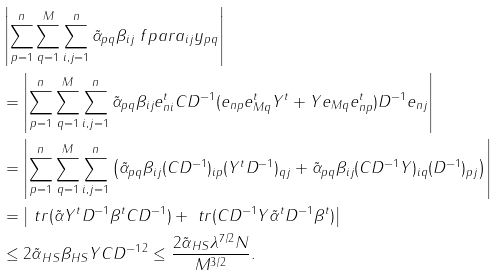Convert formula to latex. <formula><loc_0><loc_0><loc_500><loc_500>& \left | \sum _ { p = 1 } ^ { n } \sum _ { q = 1 } ^ { M } \sum _ { i , j = 1 } ^ { n } \tilde { \alpha } _ { p q } \beta _ { i j } \ f p a r { a _ { i j } } { y _ { p q } } \right | \\ & = \left | \sum _ { p = 1 } ^ { n } \sum _ { q = 1 } ^ { M } \sum _ { i , j = 1 } ^ { n } \tilde { \alpha } _ { p q } \beta _ { i j } e _ { n i } ^ { t } C D ^ { - 1 } ( e _ { n p } e _ { M q } ^ { t } Y ^ { t } + Y e _ { M q } e _ { n p } ^ { t } ) D ^ { - 1 } e _ { n j } \right | \\ & = \left | \sum _ { p = 1 } ^ { n } \sum _ { q = 1 } ^ { M } \sum _ { i , j = 1 } ^ { n } \left ( \tilde { \alpha } _ { p q } \beta _ { i j } ( C D ^ { - 1 } ) _ { i p } ( Y ^ { t } D ^ { - 1 } ) _ { q j } + \tilde { \alpha } _ { p q } \beta _ { i j } ( C D ^ { - 1 } Y ) _ { i q } ( D ^ { - 1 } ) _ { p j } \right ) \right | \\ & = \left | \ t r ( \tilde { \alpha } Y ^ { t } D ^ { - 1 } \beta ^ { t } C D ^ { - 1 } ) + \ t r ( C D ^ { - 1 } Y \tilde { \alpha } ^ { t } D ^ { - 1 } \beta ^ { t } ) \right | \\ & \leq 2 \| \tilde { \alpha } \| _ { H S } \| \beta \| _ { H S } \| Y \| C \| D ^ { - 1 } \| ^ { 2 } \leq \frac { 2 \| \tilde { \alpha } \| _ { H S } \lambda ^ { 7 / 2 } N } { M ^ { 3 / 2 } } .</formula> 